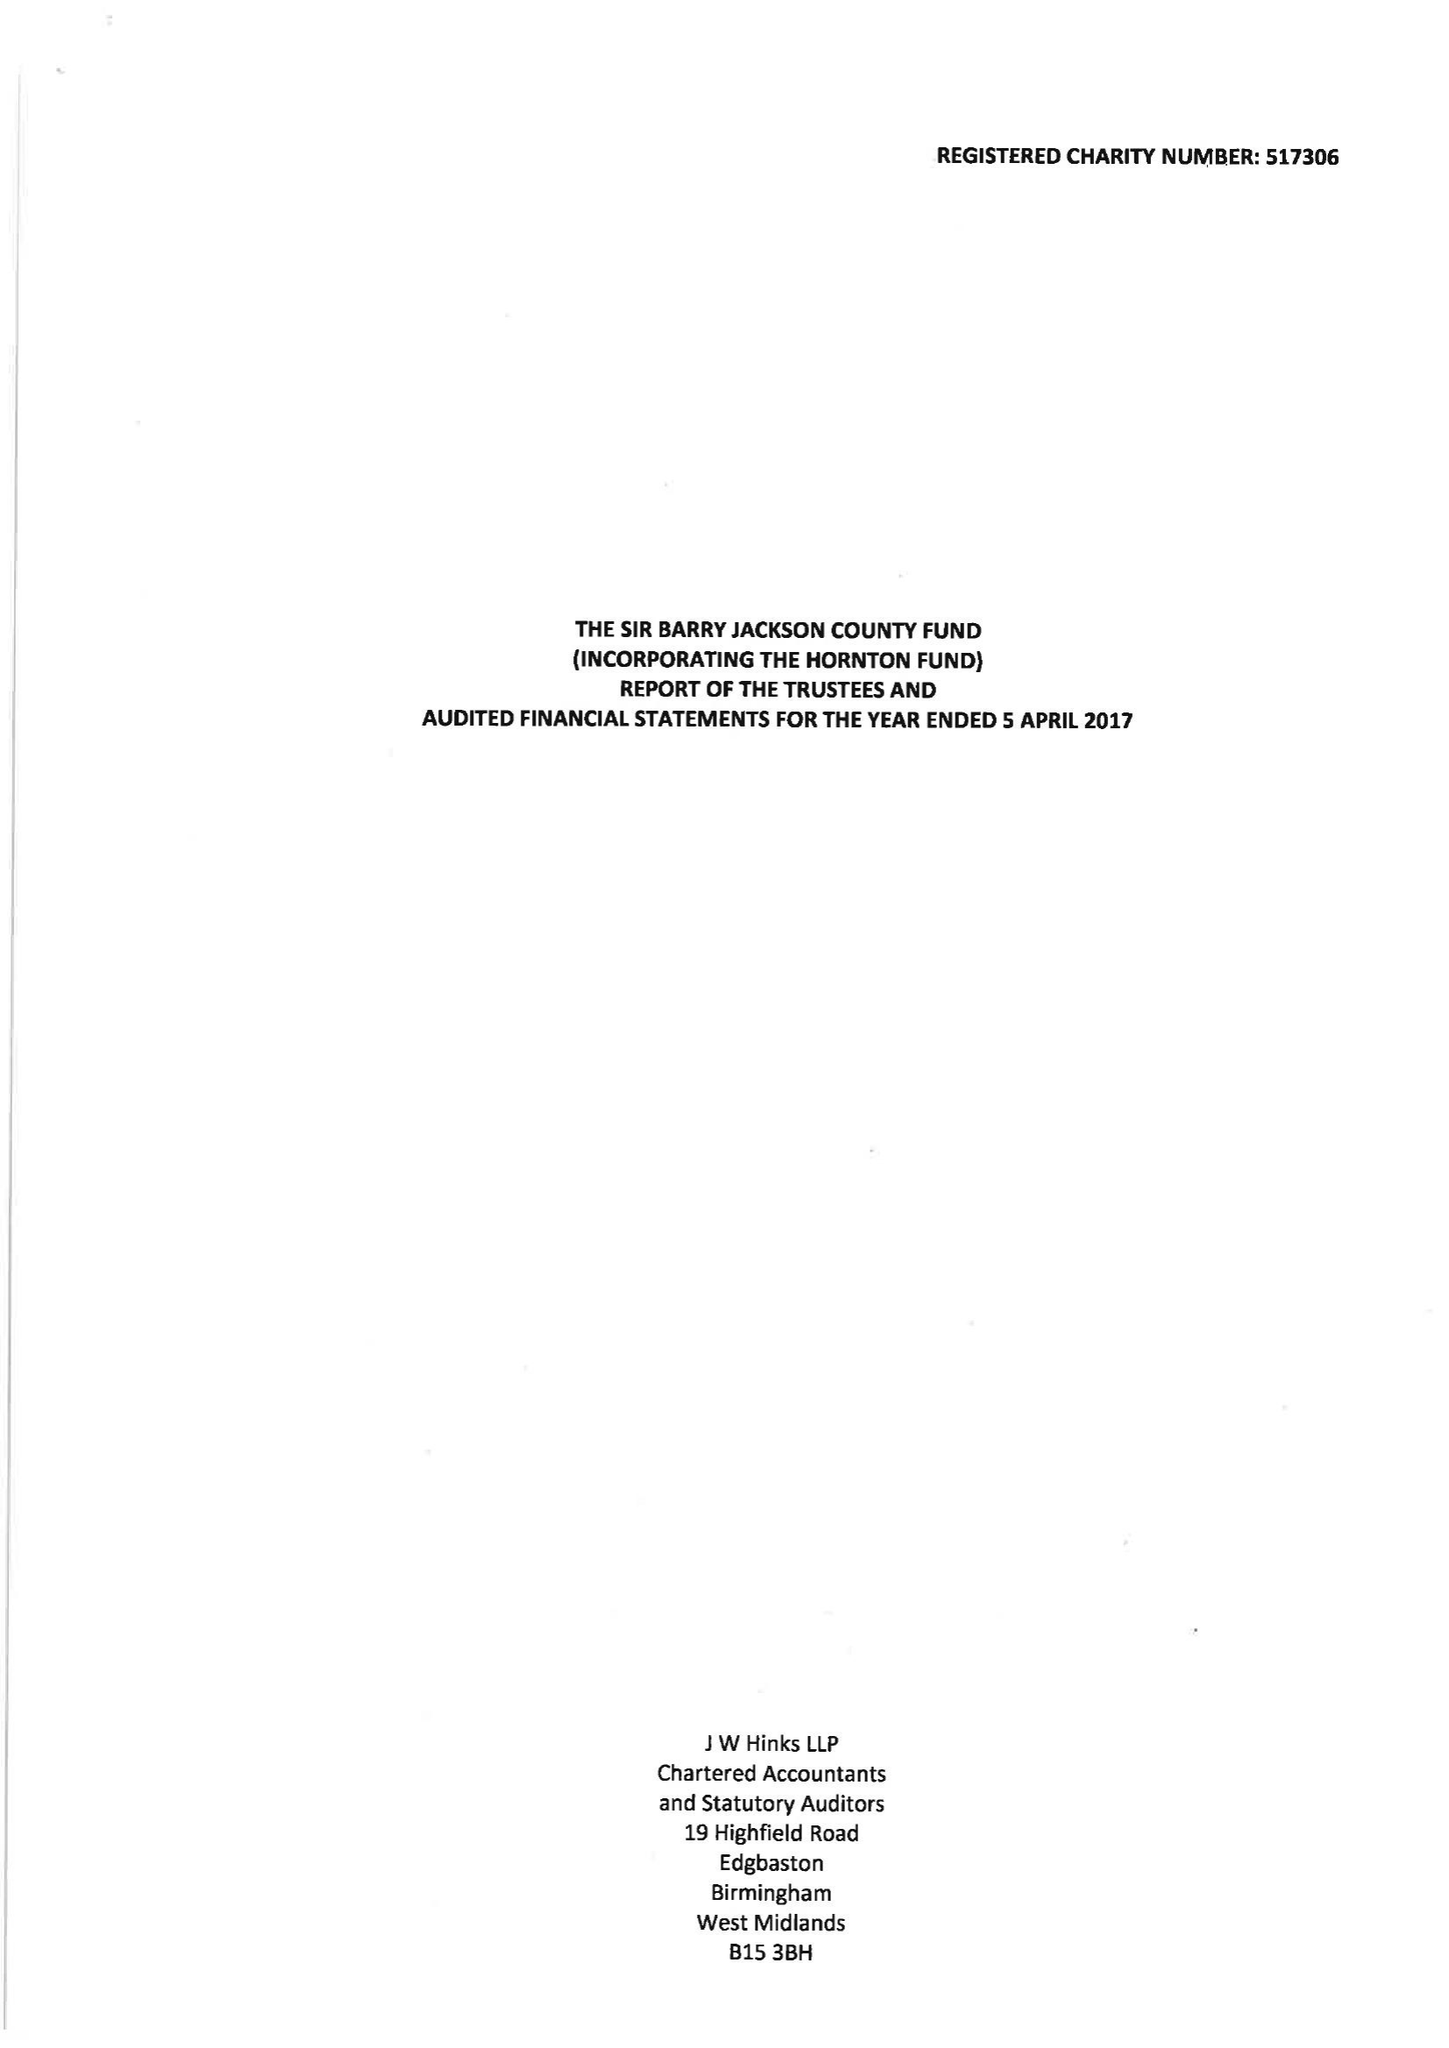What is the value for the address__post_town?
Answer the question using a single word or phrase. BIRMINGHAM 